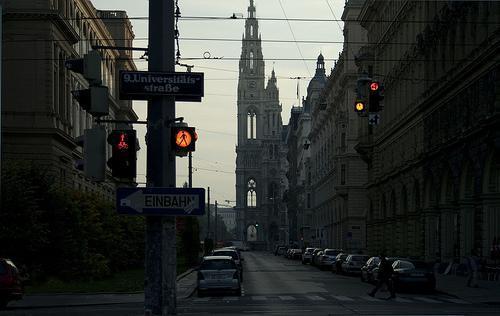How many lights are on?
Give a very brief answer. 4. How many people are in the photo?
Give a very brief answer. 1. 